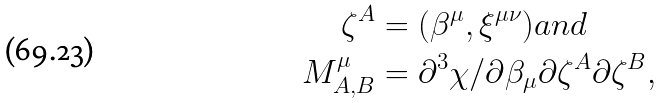Convert formula to latex. <formula><loc_0><loc_0><loc_500><loc_500>\zeta ^ { A } & = ( \beta ^ { \mu } , \xi ^ { \mu \nu } ) a n d \\ M ^ { \mu } _ { A , B } & = \partial ^ { 3 } \chi / \partial \beta _ { \mu } \partial \zeta ^ { A } \partial \zeta ^ { B } ,</formula> 